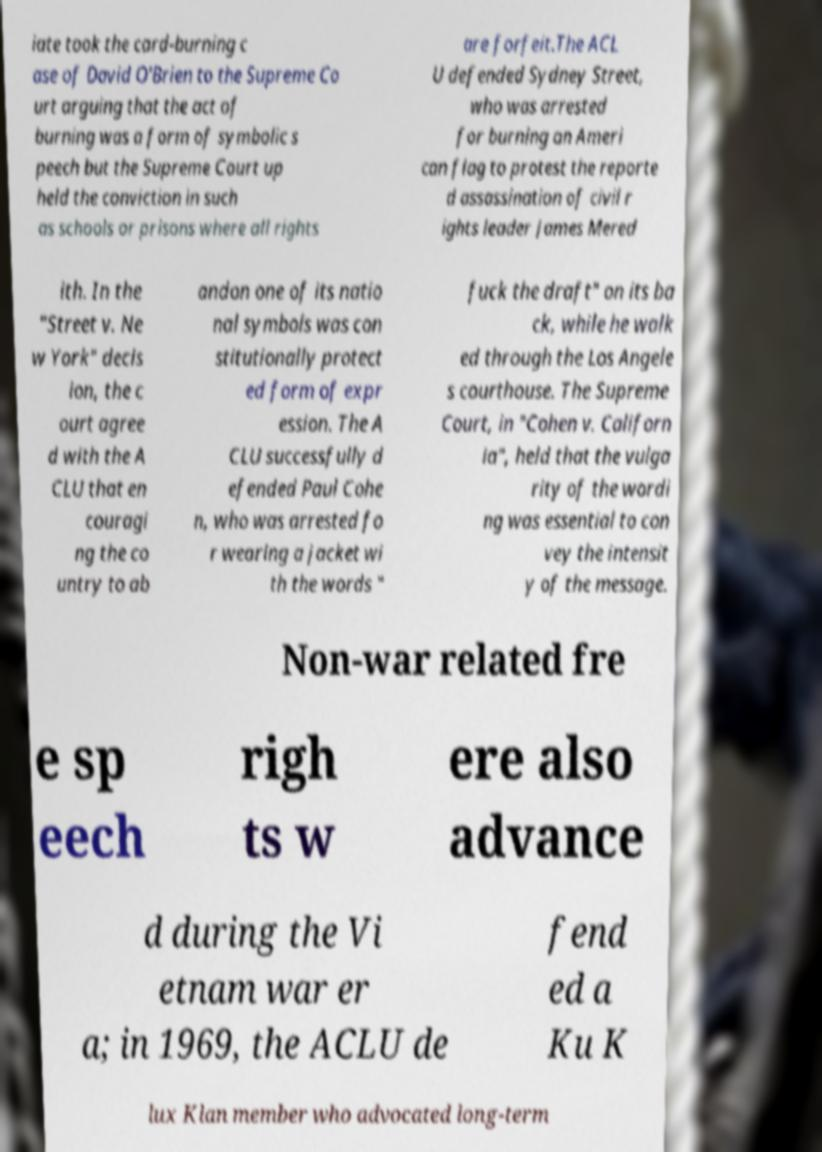Can you accurately transcribe the text from the provided image for me? iate took the card-burning c ase of David O'Brien to the Supreme Co urt arguing that the act of burning was a form of symbolic s peech but the Supreme Court up held the conviction in such as schools or prisons where all rights are forfeit.The ACL U defended Sydney Street, who was arrested for burning an Ameri can flag to protest the reporte d assassination of civil r ights leader James Mered ith. In the "Street v. Ne w York" decis ion, the c ourt agree d with the A CLU that en couragi ng the co untry to ab andon one of its natio nal symbols was con stitutionally protect ed form of expr ession. The A CLU successfully d efended Paul Cohe n, who was arrested fo r wearing a jacket wi th the words " fuck the draft" on its ba ck, while he walk ed through the Los Angele s courthouse. The Supreme Court, in "Cohen v. Californ ia", held that the vulga rity of the wordi ng was essential to con vey the intensit y of the message. Non-war related fre e sp eech righ ts w ere also advance d during the Vi etnam war er a; in 1969, the ACLU de fend ed a Ku K lux Klan member who advocated long-term 